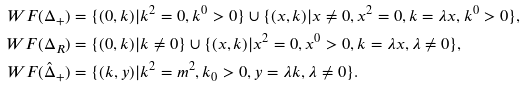Convert formula to latex. <formula><loc_0><loc_0><loc_500><loc_500>\ W F ( \Delta _ { + } ) & = \{ ( 0 , k ) | k ^ { 2 } = 0 , k ^ { 0 } > 0 \} \cup \{ ( x , k ) | x \neq 0 , x ^ { 2 } = 0 , k = \lambda x , k ^ { 0 } > 0 \} , \\ \ W F ( \Delta _ { R } ) & = \{ ( 0 , k ) | k \neq 0 \} \cup \{ ( x , k ) | x ^ { 2 } = 0 , x ^ { 0 } > 0 , k = \lambda x , \lambda \neq 0 \} , \\ \ W F ( \hat { \Delta } _ { + } ) & = \{ ( k , y ) | k ^ { 2 } = m ^ { 2 } , k _ { 0 } > 0 , y = \lambda k , \lambda \neq 0 \} .</formula> 